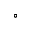Convert formula to latex. <formula><loc_0><loc_0><loc_500><loc_500>^ { \circ }</formula> 